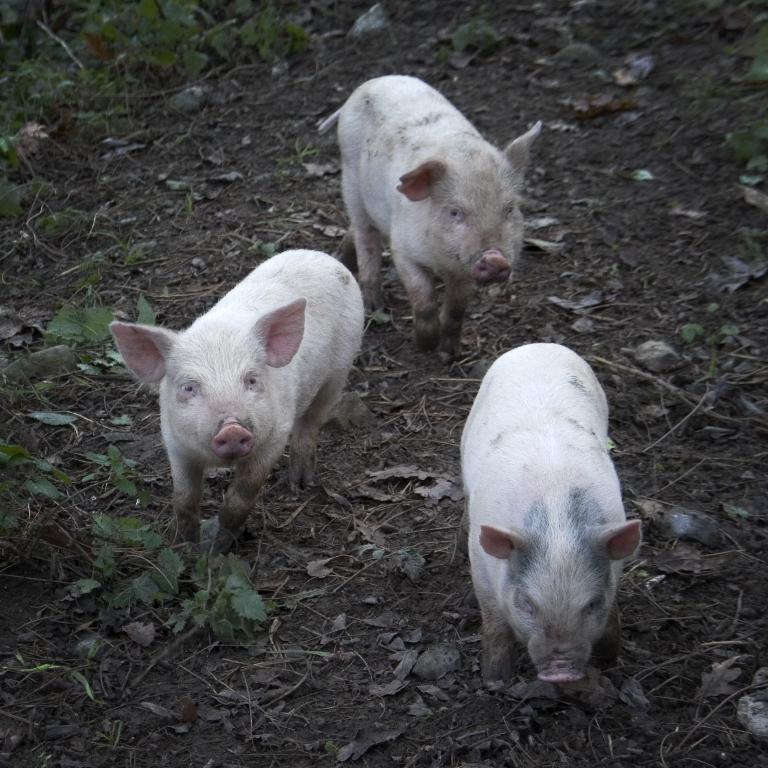How many pigs are in the image? There are three pigs in the image. What other elements can be seen in the image besides the pigs? There are plants, leaves, and soil visible in the image. What type of tray is being used to hold the wax in the image? There is no tray or wax present in the image. What type of yam is growing in the image? There is no yam present in the image. 